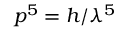<formula> <loc_0><loc_0><loc_500><loc_500>p ^ { 5 } = h / \lambda ^ { 5 }</formula> 